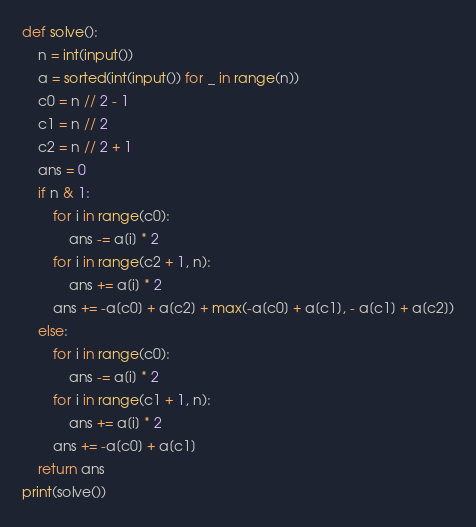Convert code to text. <code><loc_0><loc_0><loc_500><loc_500><_Python_>def solve():
    n = int(input())
    a = sorted(int(input()) for _ in range(n))
    c0 = n // 2 - 1
    c1 = n // 2
    c2 = n // 2 + 1
    ans = 0
    if n & 1:
        for i in range(c0):
            ans -= a[i] * 2
        for i in range(c2 + 1, n):
            ans += a[i] * 2
        ans += -a[c0] + a[c2] + max(-a[c0] + a[c1], - a[c1] + a[c2])
    else:
        for i in range(c0):
            ans -= a[i] * 2
        for i in range(c1 + 1, n):
            ans += a[i] * 2
        ans += -a[c0] + a[c1]
    return ans
print(solve())
</code> 